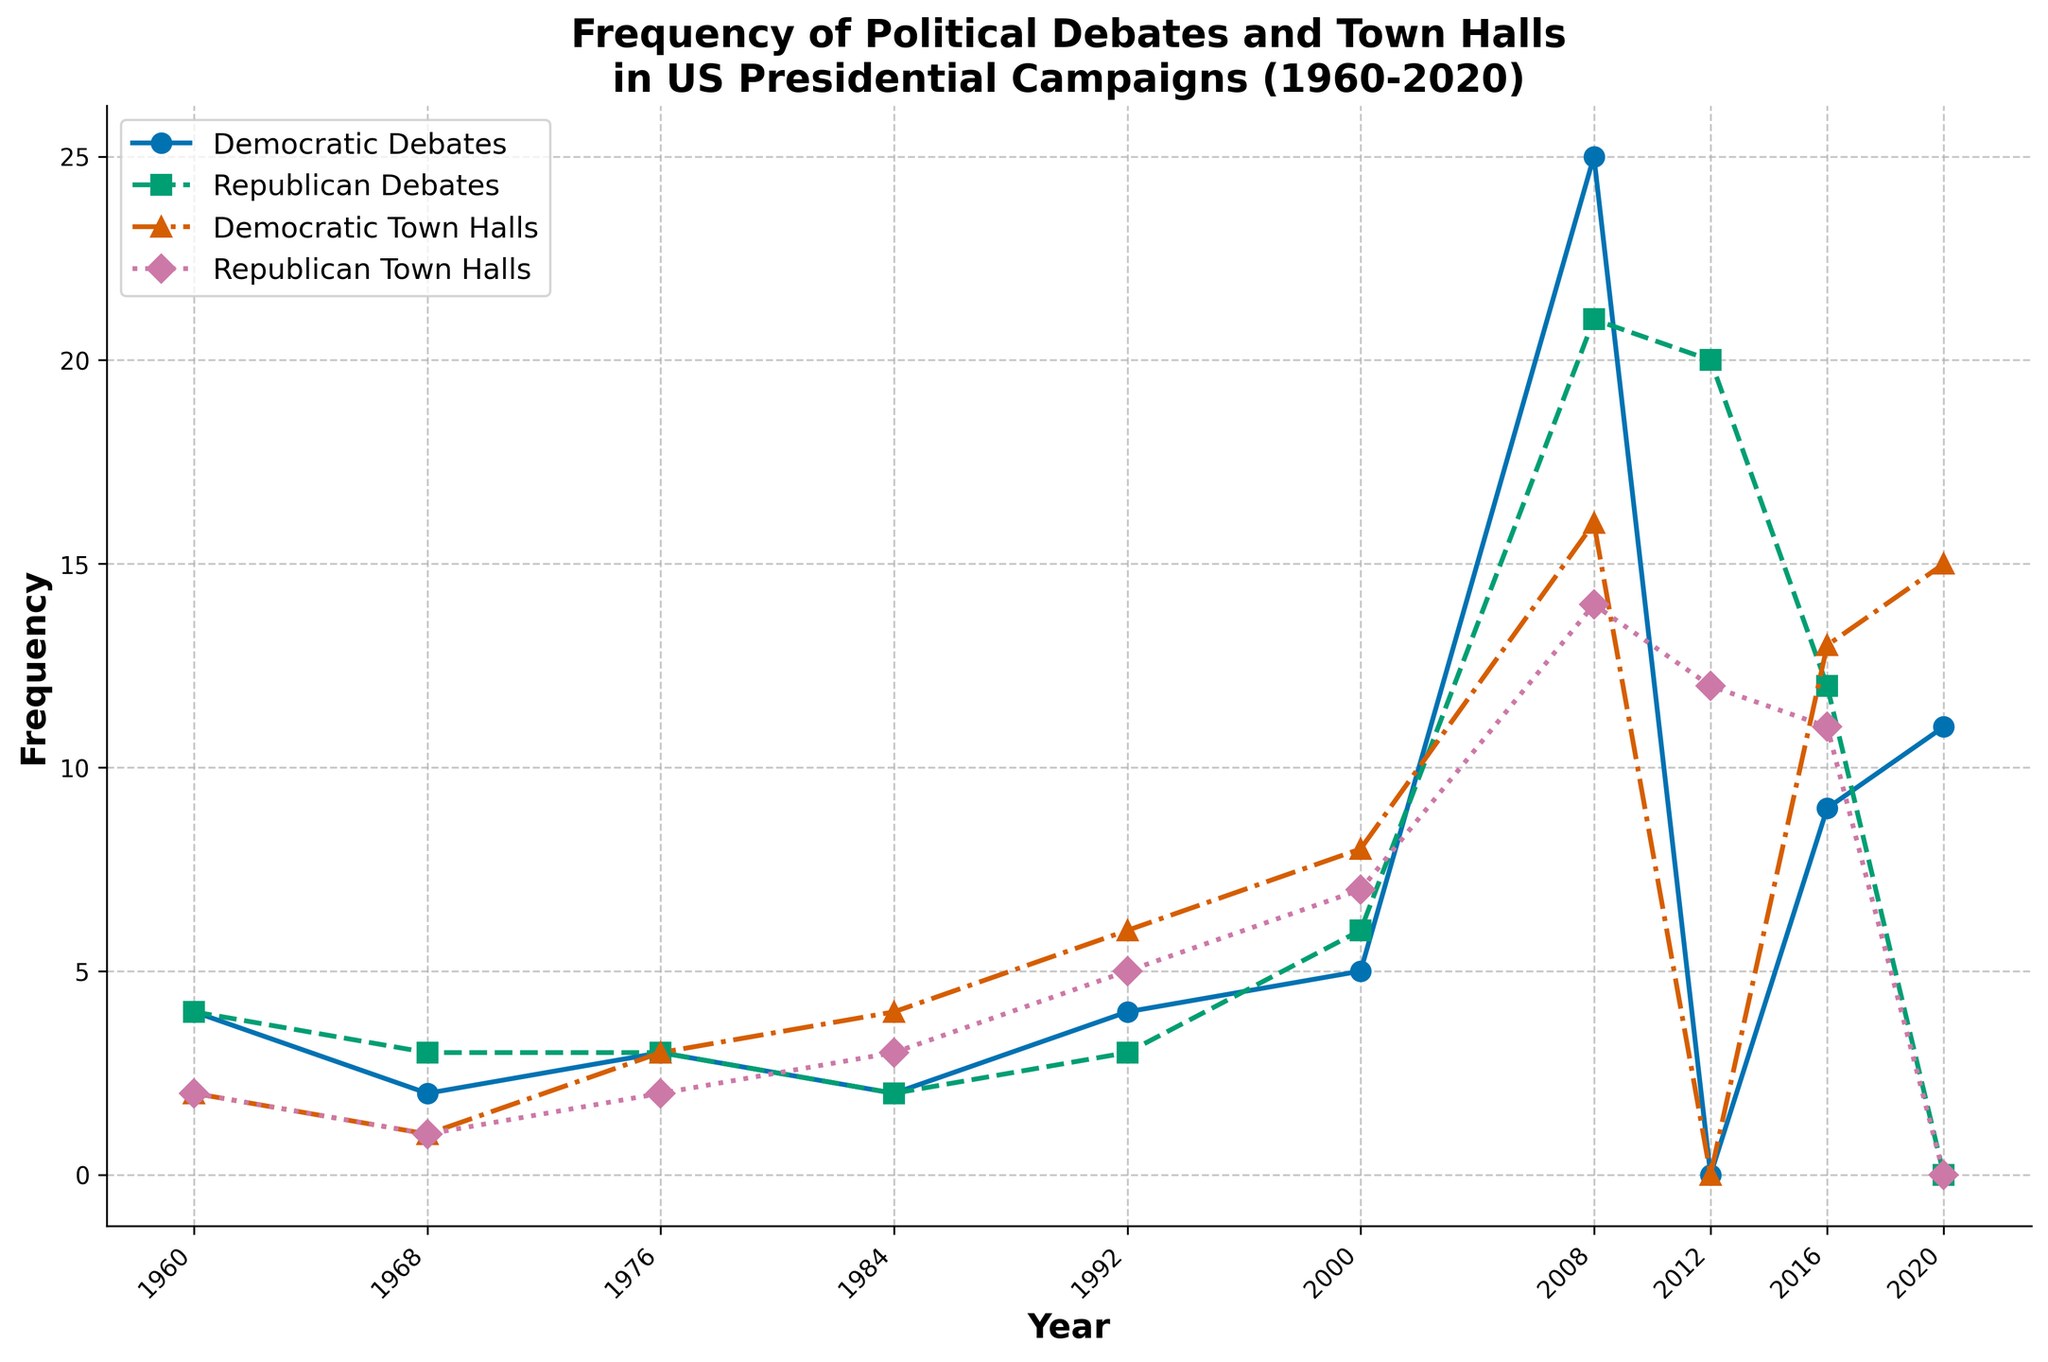What year had the highest number of Democratic Debates? To find this answer, we look at the line representing Democratic Debates and find the peak point. The highest value observed is in the year 2008.
Answer: 2008 Which party had more debates in the year 2000? We compare the Democratic Debates and Republican Debates points for 2000. The Democratic Debates are at 5, and the Republican Debates are at 6. Therefore, the Republicans had more debates in 2000.
Answer: Republicans In which year were there zero Republican Debates and zero Republican Town Halls? By inspecting the chart, the only year where both Republican Debates and Republican Town Halls are at zero is 2020.
Answer: 2020 What's the total number of town halls (both Democratic and Republican) in 1992? Adding the Democratic Town Halls (6) and Republican Town Halls (5) shown in the chart for the year 1992, we get a total of 6 + 5 = 11.
Answer: 11 Are there more Democratic or Republican Town Halls in the year 2016? Referring to 2016, the number of Democratic Town Halls is 13 and the number of Republican Town Halls is 11, so there are more Democratic Town Halls.
Answer: Democratic Which year shows the closest number of Democratic Debates and Town Halls? We need to find the year where the values of Democratic Debates and Town Halls are closest. By comparison, 2016 shows this as the Democratic Debates are 9 and the Town Halls are 13, a difference of 4, which is the closest among all years.
Answer: 2016 What's the average number of Republican Debates from 1960 to 2020? Sum the Republican Debates (4 + 3 + 3 + 2 + 3 + 6 + 21 + 20 + 12 + 0), which equals 74. Then, divide by the number of years, 10: 74/10 = 7.4.
Answer: 7.4 What's the difference in the number of Democratic debates between 2008 and 2012? In 2008, there were 25 Democratic Debates, and in 2012, there were 0. So, the difference is 25 - 0 = 25.
Answer: 25 Which year had the highest combined total (Debates + Town Halls) for any party? To answer this, calculate the combined totals for each year. In 2008, Democrats had 25 (Debates) + 16 (Town Halls) = 41, which is the highest combined total for any party in any year.
Answer: 2008 Which party had a greater increase in debates from 1968 to 1976? In 1968, Democrats had 2 and Republicans had 3 debates. In 1976, both had 3 debates. The increase for Democrats is 3 - 2 = 1 and Republicans is 3 - 3 = 0. So, the Democrats had a greater increase.
Answer: Democrats 